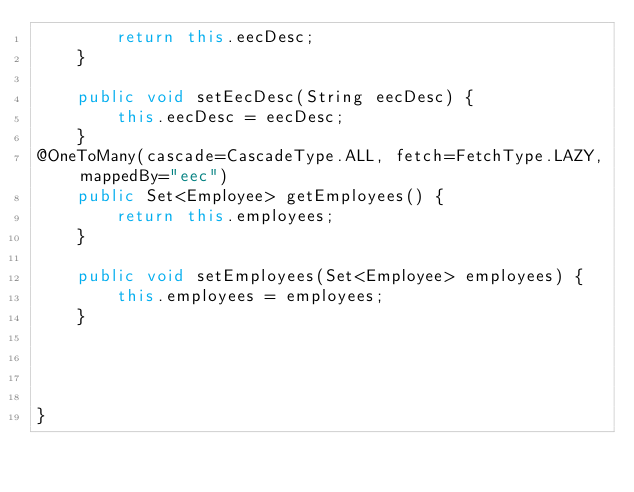<code> <loc_0><loc_0><loc_500><loc_500><_Java_>        return this.eecDesc;
    }
    
    public void setEecDesc(String eecDesc) {
        this.eecDesc = eecDesc;
    }
@OneToMany(cascade=CascadeType.ALL, fetch=FetchType.LAZY, mappedBy="eec")
    public Set<Employee> getEmployees() {
        return this.employees;
    }
    
    public void setEmployees(Set<Employee> employees) {
        this.employees = employees;
    }




}


</code> 